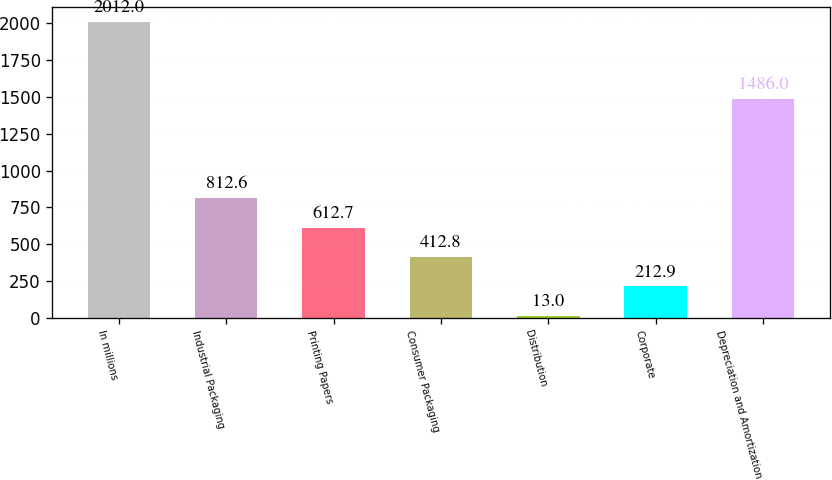<chart> <loc_0><loc_0><loc_500><loc_500><bar_chart><fcel>In millions<fcel>Industrial Packaging<fcel>Printing Papers<fcel>Consumer Packaging<fcel>Distribution<fcel>Corporate<fcel>Depreciation and Amortization<nl><fcel>2012<fcel>812.6<fcel>612.7<fcel>412.8<fcel>13<fcel>212.9<fcel>1486<nl></chart> 